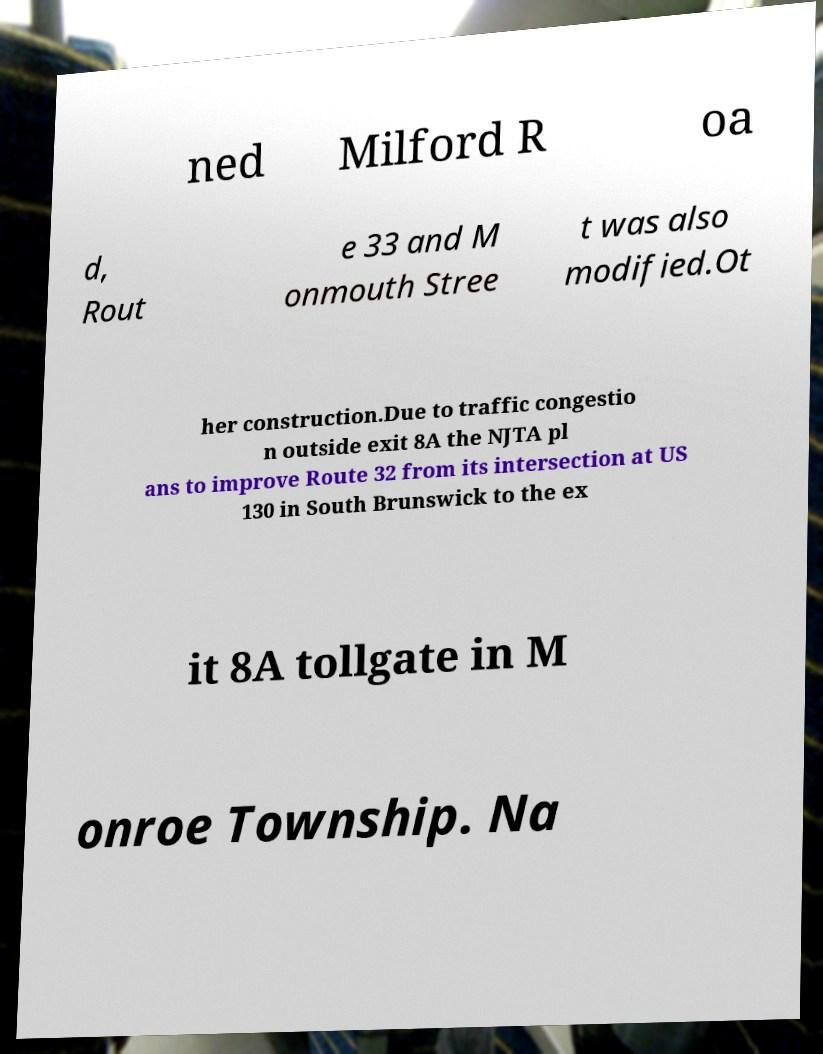Please identify and transcribe the text found in this image. ned Milford R oa d, Rout e 33 and M onmouth Stree t was also modified.Ot her construction.Due to traffic congestio n outside exit 8A the NJTA pl ans to improve Route 32 from its intersection at US 130 in South Brunswick to the ex it 8A tollgate in M onroe Township. Na 